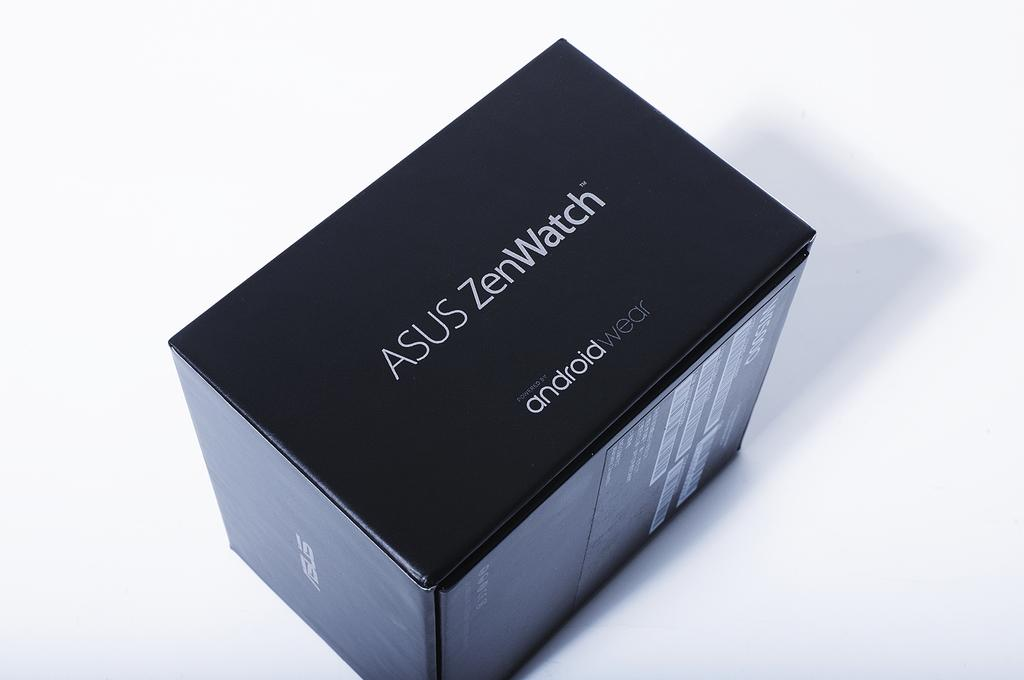<image>
Provide a brief description of the given image. An all black Asus ZenWatch box with white writing. 